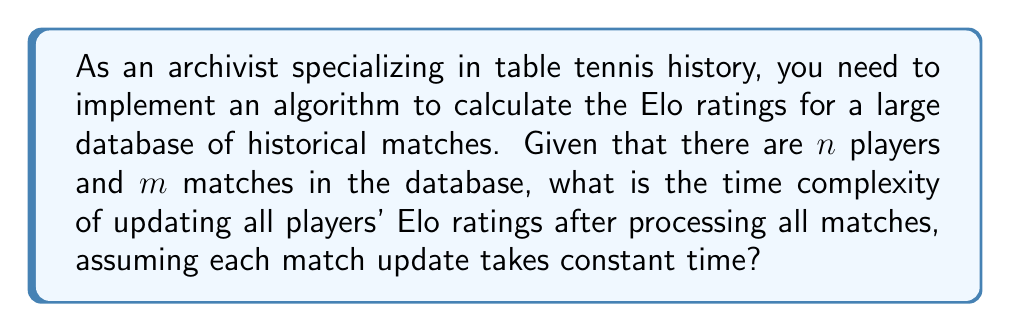Show me your answer to this math problem. To solve this problem, let's break it down step by step:

1) First, we need to understand what Elo rating is:
   Elo rating is a method for calculating the relative skill levels of players in two-player games.

2) For each match, we need to update the Elo ratings of both players involved. This update process is assumed to take constant time, let's call it $O(1)$.

3) Now, let's consider the given information:
   - There are $n$ players in the database
   - There are $m$ matches in the database

4) For each match, we perform two constant-time operations (updating each player's rating):
   Time per match = $O(1) + O(1) = O(1)$

5) We need to process all $m$ matches:
   Total time = $m * O(1) = O(m)$

6) The number of players $n$ doesn't directly affect the time complexity in this case, because we're only updating ratings based on matches played.

7) Therefore, the overall time complexity of updating all players' Elo ratings after processing all matches is $O(m)$.

This linear time complexity means that the processing time will increase linearly with the number of matches in the database, regardless of the number of players.
Answer: $O(m)$, where $m$ is the number of matches in the database. 